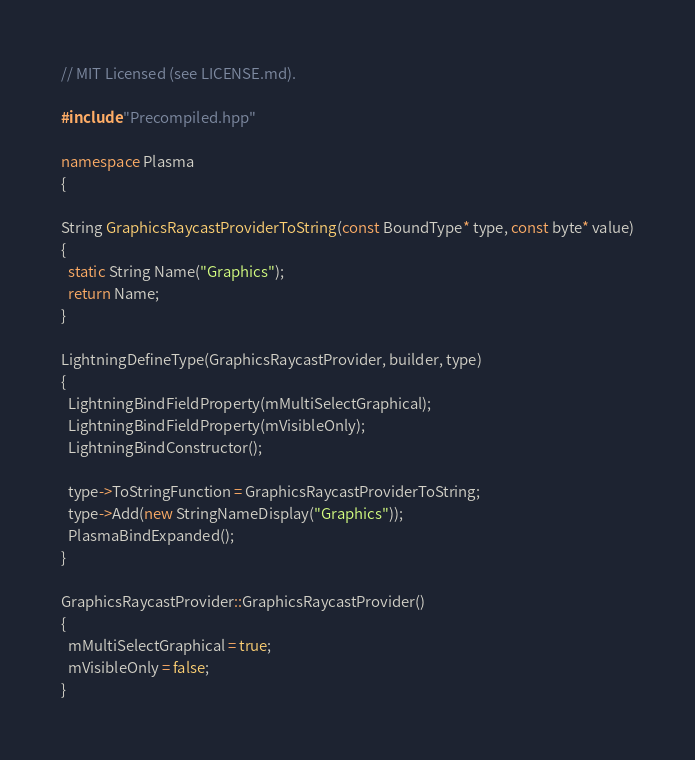Convert code to text. <code><loc_0><loc_0><loc_500><loc_500><_C++_>// MIT Licensed (see LICENSE.md).

#include "Precompiled.hpp"

namespace Plasma
{

String GraphicsRaycastProviderToString(const BoundType* type, const byte* value)
{
  static String Name("Graphics");
  return Name;
}

LightningDefineType(GraphicsRaycastProvider, builder, type)
{
  LightningBindFieldProperty(mMultiSelectGraphical);
  LightningBindFieldProperty(mVisibleOnly);
  LightningBindConstructor();

  type->ToStringFunction = GraphicsRaycastProviderToString;
  type->Add(new StringNameDisplay("Graphics"));
  PlasmaBindExpanded();
}

GraphicsRaycastProvider::GraphicsRaycastProvider()
{
  mMultiSelectGraphical = true;
  mVisibleOnly = false;
}
</code> 